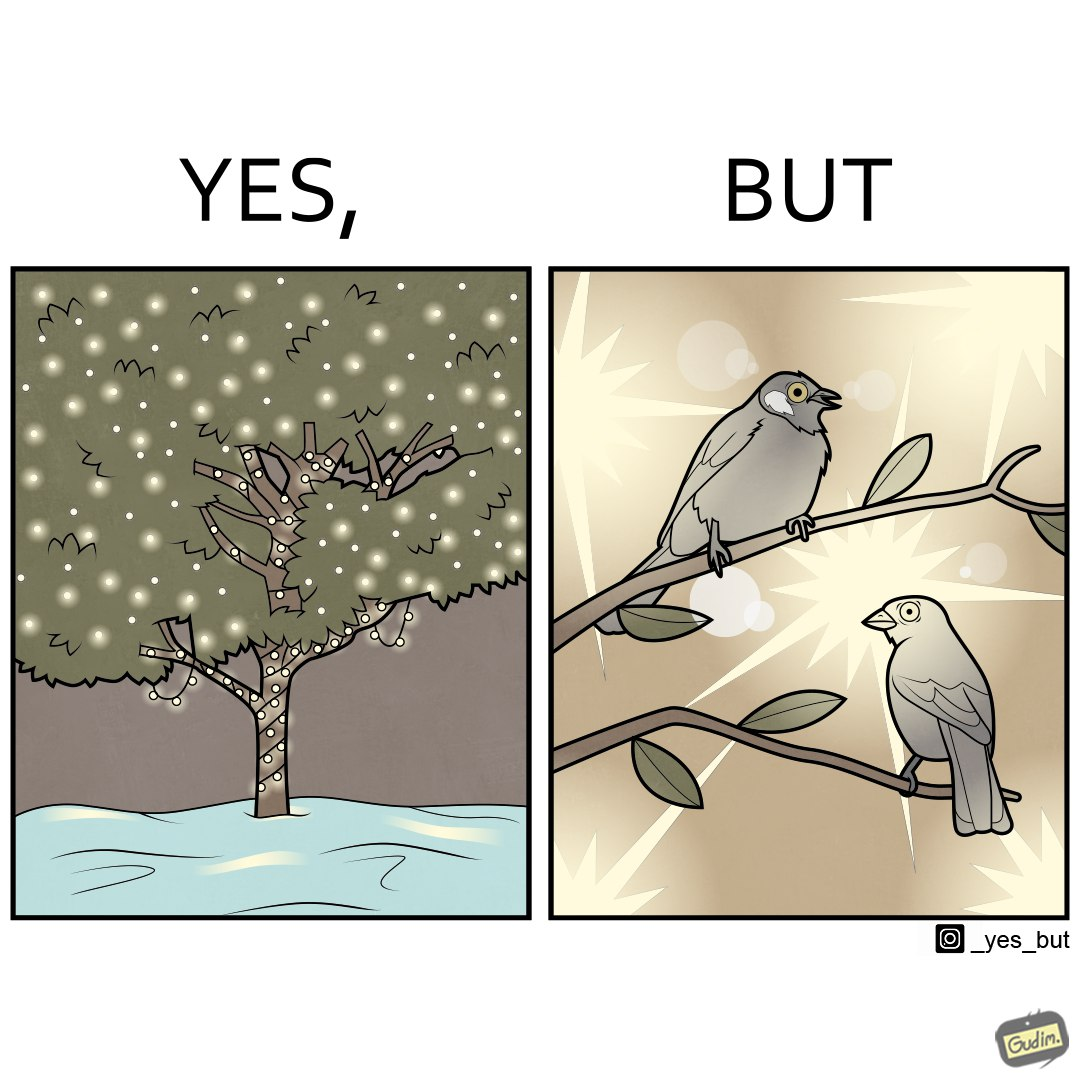Is this image satirical or non-satirical? Yes, this image is satirical. 